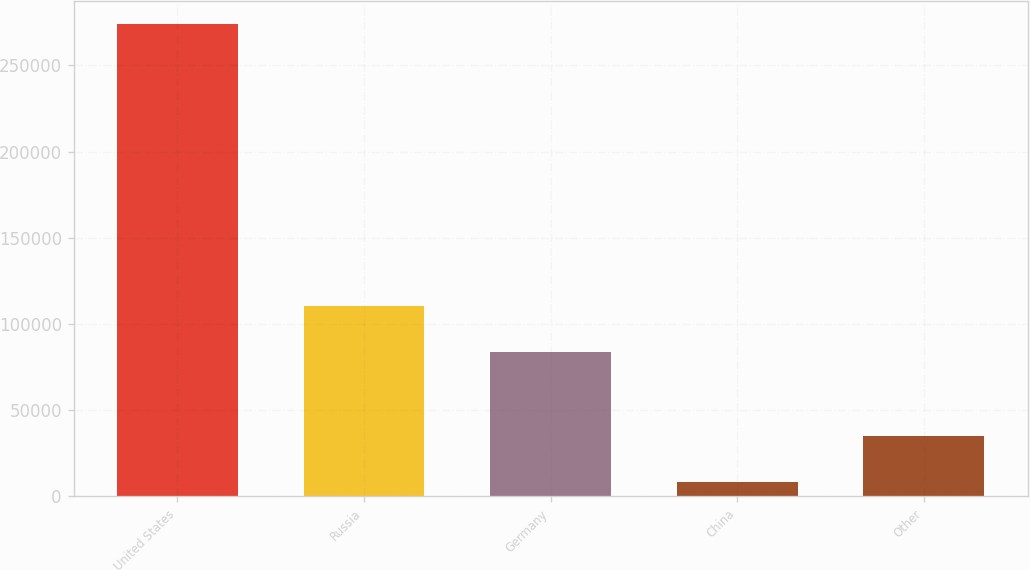Convert chart to OTSL. <chart><loc_0><loc_0><loc_500><loc_500><bar_chart><fcel>United States<fcel>Russia<fcel>Germany<fcel>China<fcel>Other<nl><fcel>273947<fcel>110402<fcel>83826<fcel>8191<fcel>34766.6<nl></chart> 